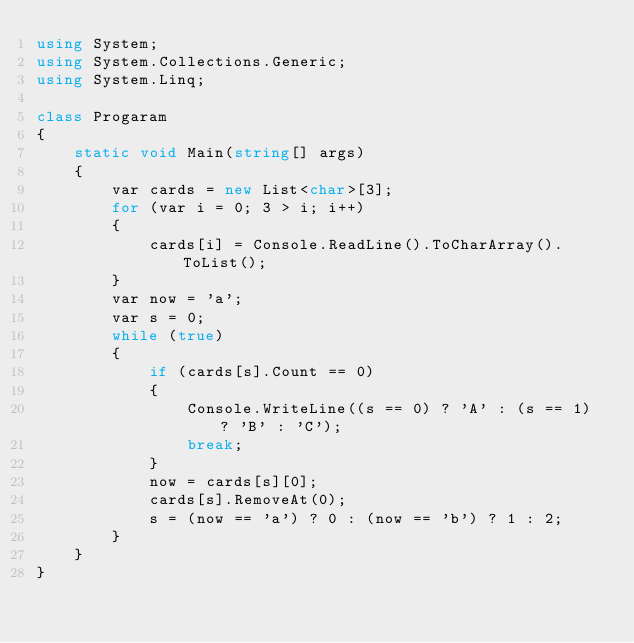<code> <loc_0><loc_0><loc_500><loc_500><_C#_>using System;
using System.Collections.Generic;
using System.Linq;

class Progaram
{
    static void Main(string[] args)
    {
        var cards = new List<char>[3];
        for (var i = 0; 3 > i; i++)
        {
            cards[i] = Console.ReadLine().ToCharArray().ToList();
        }
        var now = 'a';
        var s = 0;
        while (true)
        {
            if (cards[s].Count == 0)
            {
                Console.WriteLine((s == 0) ? 'A' : (s == 1) ? 'B' : 'C');
                break;
            }
            now = cards[s][0];
            cards[s].RemoveAt(0);
            s = (now == 'a') ? 0 : (now == 'b') ? 1 : 2;
        }
    }
}</code> 